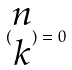Convert formula to latex. <formula><loc_0><loc_0><loc_500><loc_500>( \begin{matrix} n \\ k \end{matrix} ) = 0</formula> 